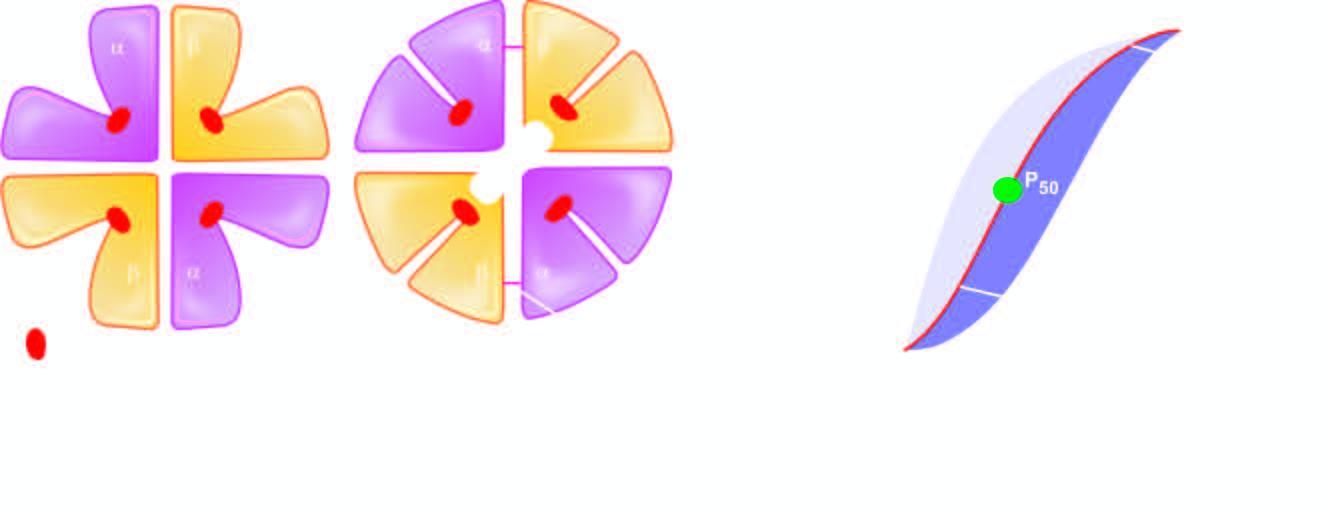what are broken?
Answer the question using a single word or phrase. Salt bridges 